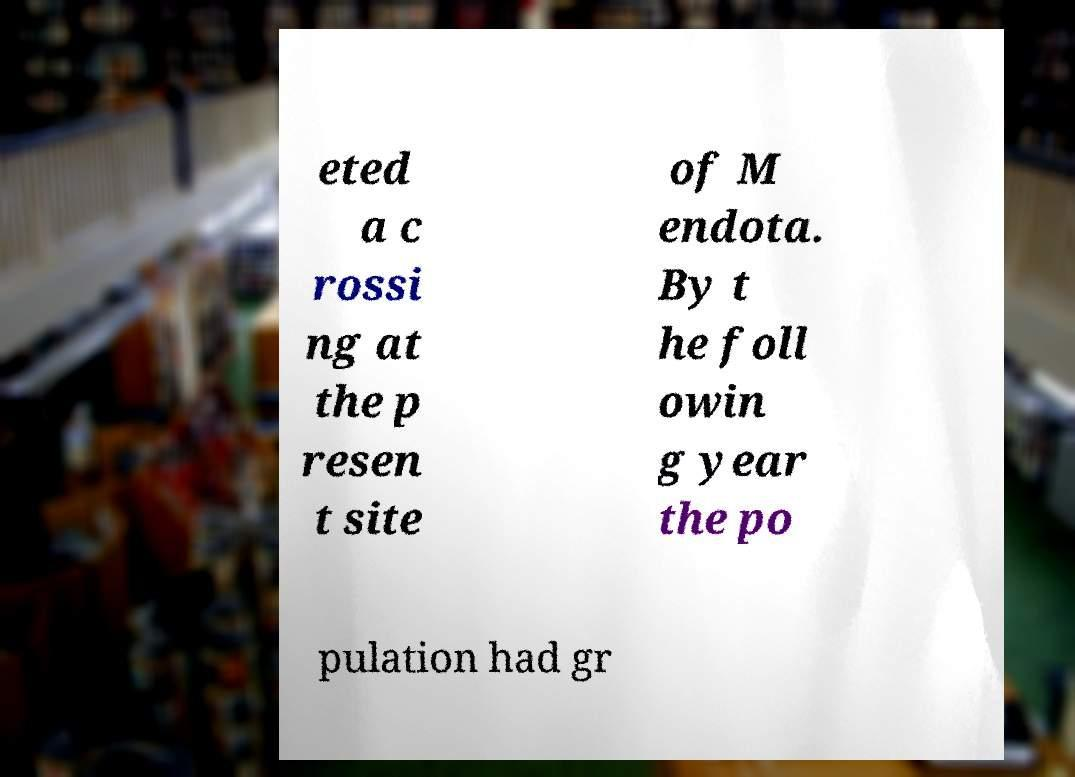Please identify and transcribe the text found in this image. eted a c rossi ng at the p resen t site of M endota. By t he foll owin g year the po pulation had gr 